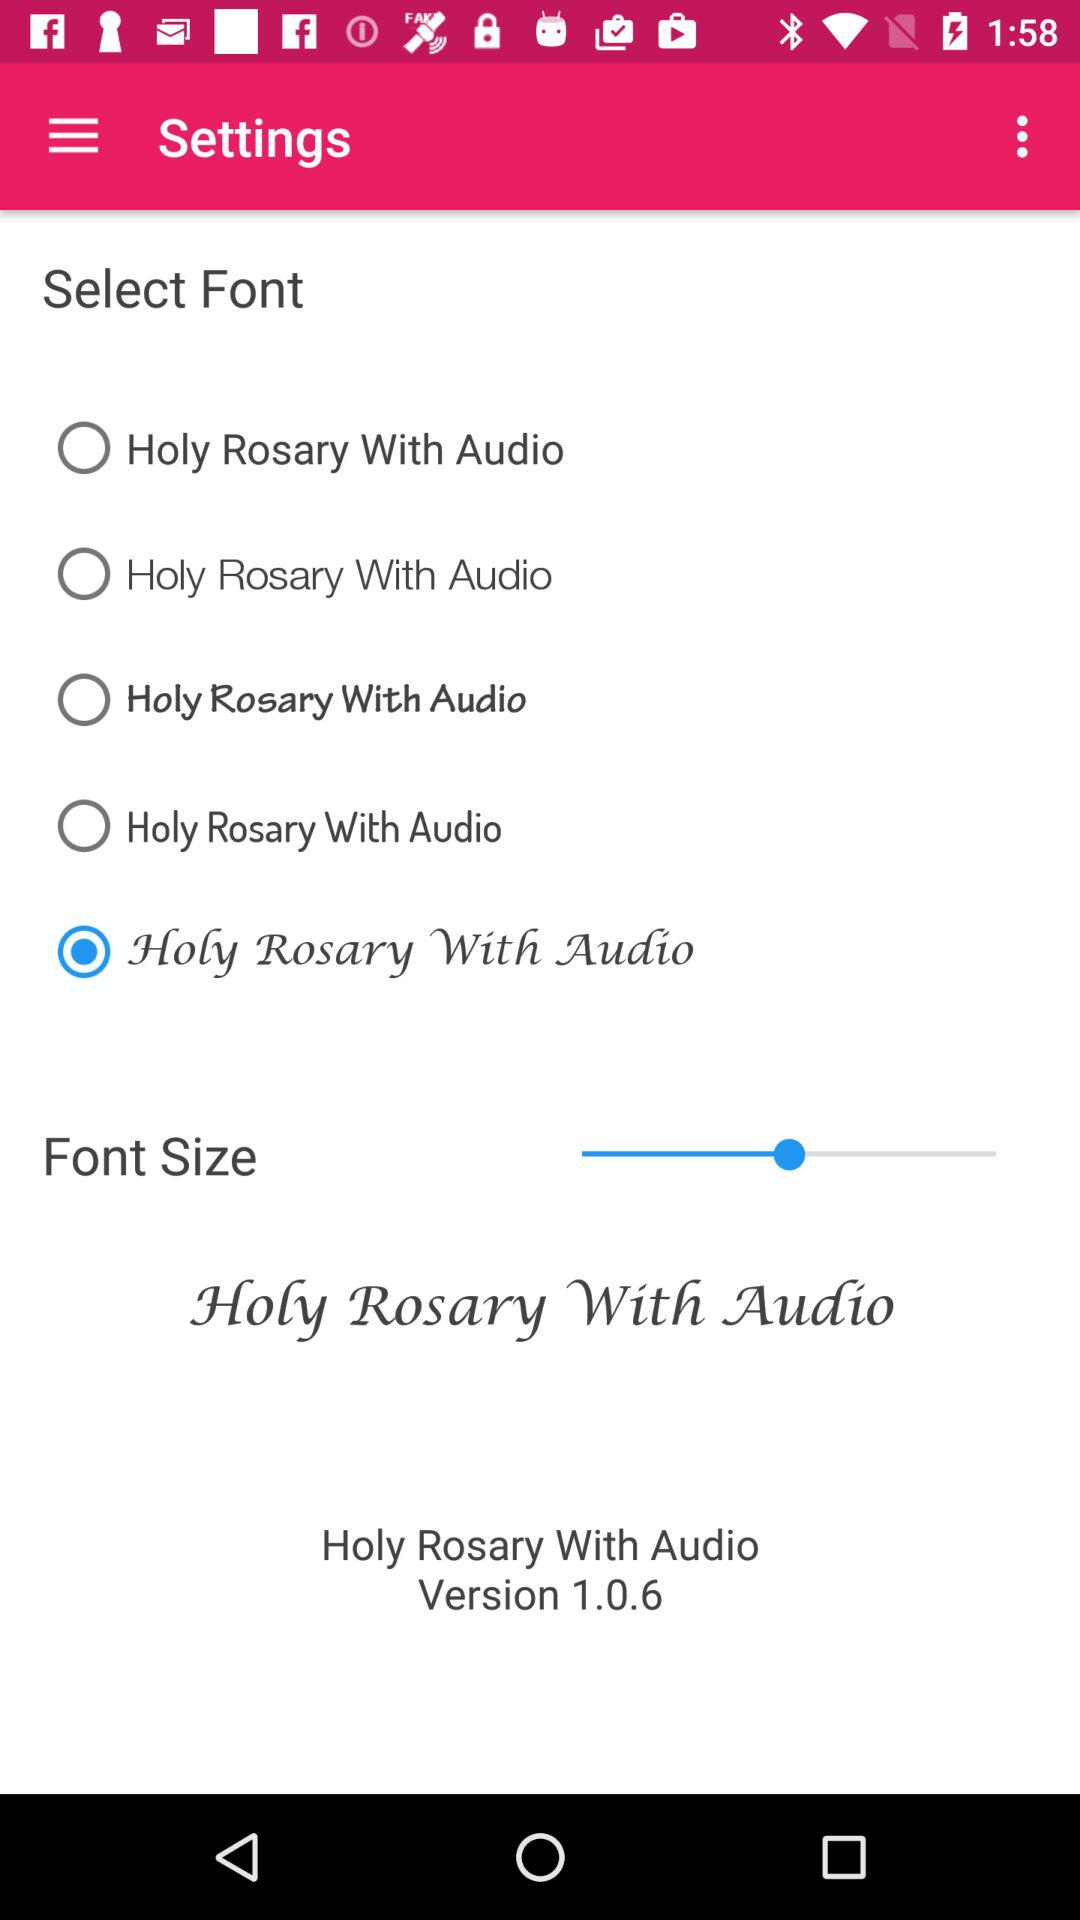Which is the selected Radio button?
When the provided information is insufficient, respond with <no answer>. <no answer> 